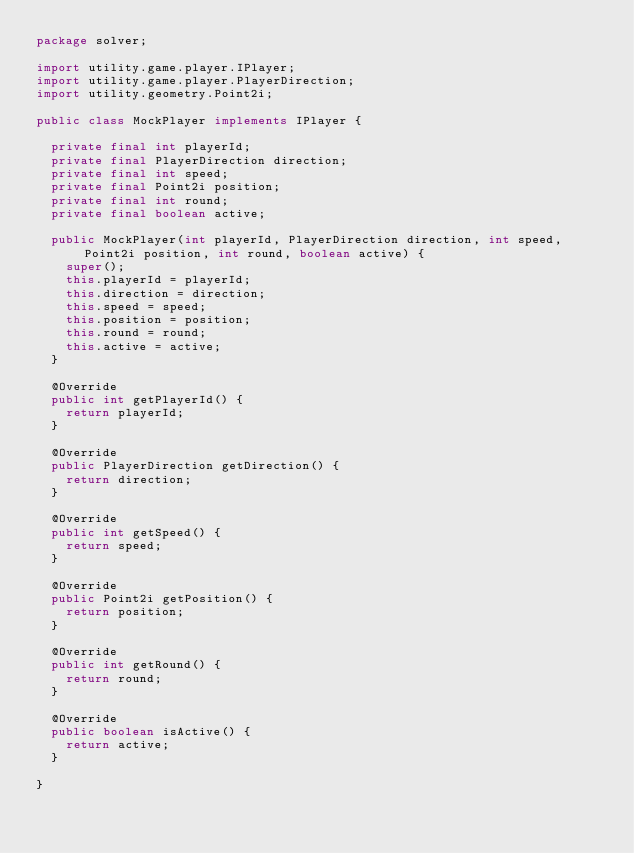Convert code to text. <code><loc_0><loc_0><loc_500><loc_500><_Java_>package solver;

import utility.game.player.IPlayer;
import utility.game.player.PlayerDirection;
import utility.geometry.Point2i;

public class MockPlayer implements IPlayer {

	private final int playerId;
	private final PlayerDirection direction;
	private final int speed;
	private final Point2i position;
	private final int round;
	private final boolean active;

	public MockPlayer(int playerId, PlayerDirection direction, int speed, Point2i position, int round, boolean active) {
		super();
		this.playerId = playerId;
		this.direction = direction;
		this.speed = speed;
		this.position = position;
		this.round = round;
		this.active = active;
	}

	@Override
	public int getPlayerId() {
		return playerId;
	}

	@Override
	public PlayerDirection getDirection() {
		return direction;
	}

	@Override
	public int getSpeed() {
		return speed;
	}

	@Override
	public Point2i getPosition() {
		return position;
	}

	@Override
	public int getRound() {
		return round;
	}

	@Override
	public boolean isActive() {
		return active;
	}

}
</code> 